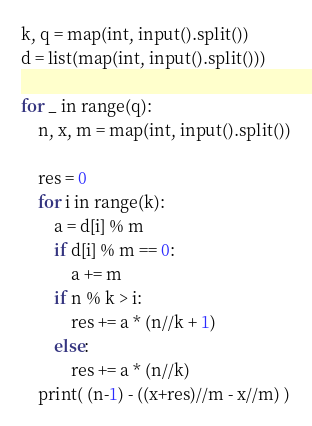Convert code to text. <code><loc_0><loc_0><loc_500><loc_500><_Python_>k, q = map(int, input().split())
d = list(map(int, input().split()))

for _ in range(q):
	n, x, m = map(int, input().split())

	res = 0
	for i in range(k):
		a = d[i] % m
		if d[i] % m == 0:
			a += m
		if n % k > i:
			res += a * (n//k + 1)
		else:
			res += a * (n//k)
	print( (n-1) - ((x+res)//m - x//m) )
</code> 